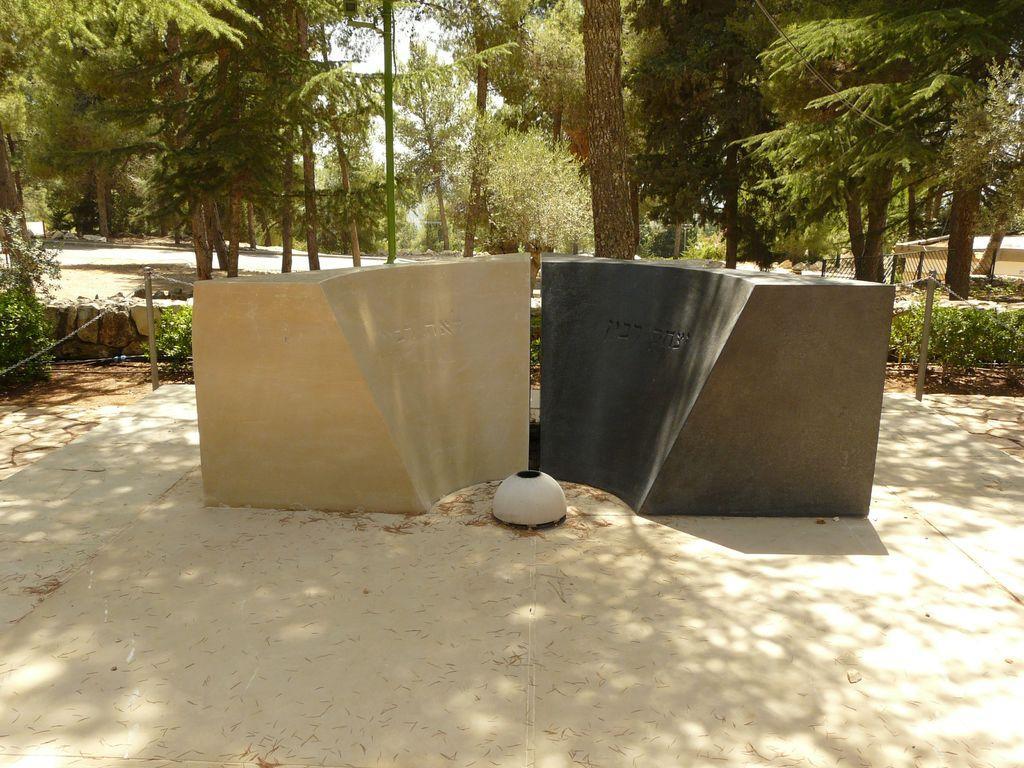Please provide a concise description of this image. In the center of the image we can see the stones. In the background of the image we can see trees, mesh, some bushes, rocks, road, house. At the top of the image we can see the sky. At the bottom of the image we can see the ground. 